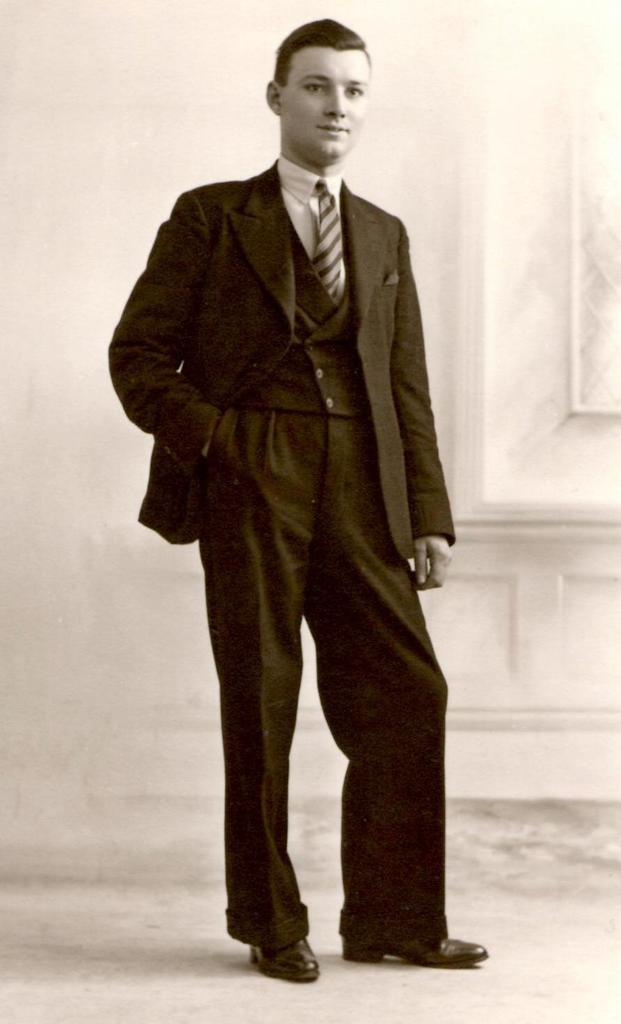What is the color scheme of the image? The image is black and white. Can you describe the person in the image? There is a person standing in the image. Where is the person standing? The person is standing on the floor. What can be seen in the background of the image? There is a wall in the background of the image. What type of leaf is covering the person in the image? There is no leaf present in the image, and the person is not covered by any object. 